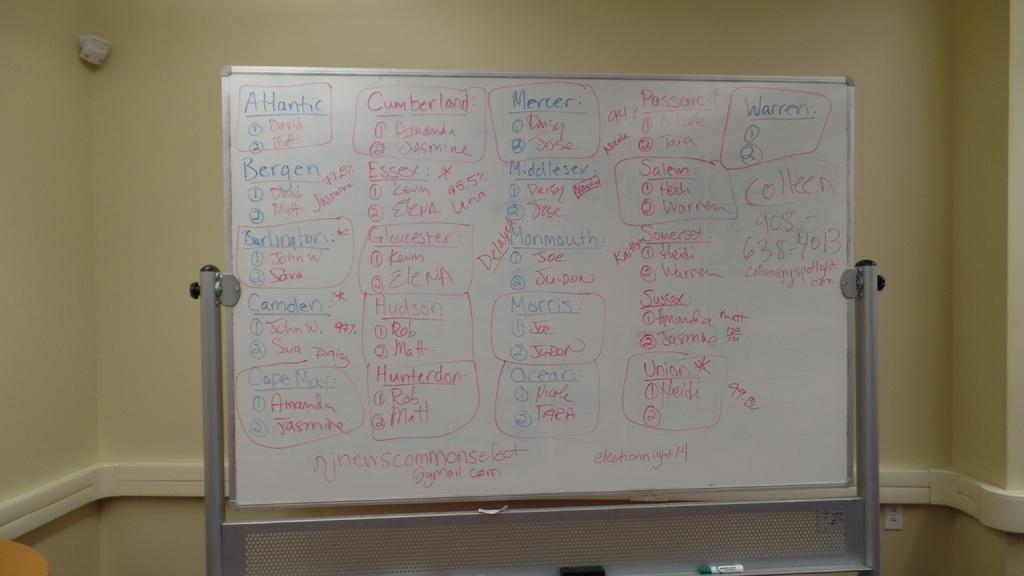<image>
Share a concise interpretation of the image provided. Whiteboard with red and blue markers and Atantic with names below 